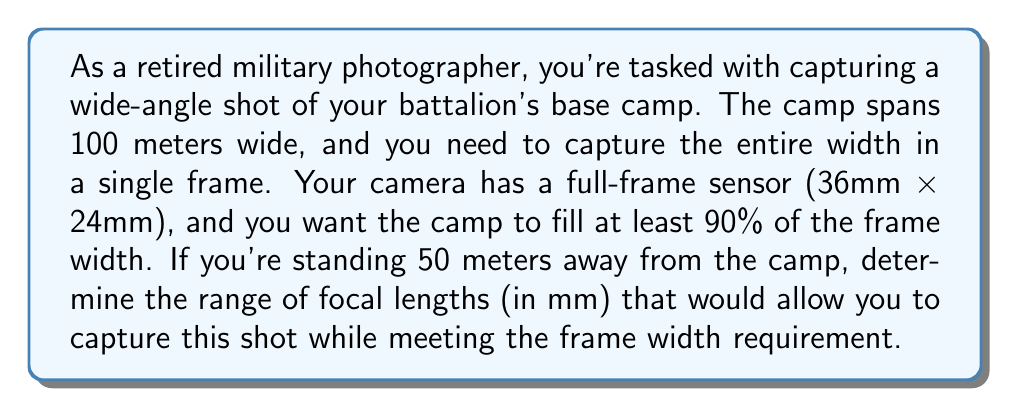Can you solve this math problem? To solve this problem, we need to use the relationship between focal length, sensor size, subject size, and distance. We'll use the formula for the angle of view and then convert it to focal length.

1. Calculate the minimum angle of view required:
   The camp should fill at least 90% of the frame width.
   Minimum angle of view = $2 \cdot \arctan(\frac{100/2}{50}) \approx 90^\circ$

2. Use the angle of view formula to find the maximum focal length:
   $$\text{Angle of View} = 2 \cdot \arctan(\frac{\text{sensor width}}{2f})$$
   Where $f$ is the focal length.

   $90^\circ = 2 \cdot \arctan(\frac{36}{2f})$
   $45^\circ = \arctan(\frac{18}{f})$
   $\tan(45^\circ) = \frac{18}{f}$
   $f = \frac{18}{\tan(45^\circ)} \approx 18$ mm

3. Calculate the minimum focal length (for 100% frame width):
   $\text{Angle of View} = 2 \cdot \arctan(\frac{100/2}{50}) \approx 90^\circ$
   
   Using the same formula:
   $90^\circ = 2 \cdot \arctan(\frac{36}{2f})$
   $45^\circ = \arctan(\frac{18}{f})$
   $f = \frac{18}{\tan(45^\circ)} \approx 18$ mm

Therefore, the range of focal lengths is from 18 mm to slightly less than 18 mm. In practical terms, since lenses typically come in discrete focal lengths, we can express this as approximately 18 mm.
Answer: The range of focal lengths to capture the required field of view is approximately 18 mm. 